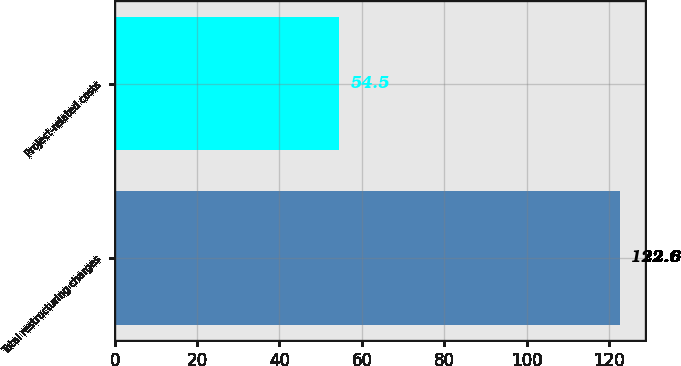<chart> <loc_0><loc_0><loc_500><loc_500><bar_chart><fcel>Total restructuring charges<fcel>Project-related costs<nl><fcel>122.6<fcel>54.5<nl></chart> 